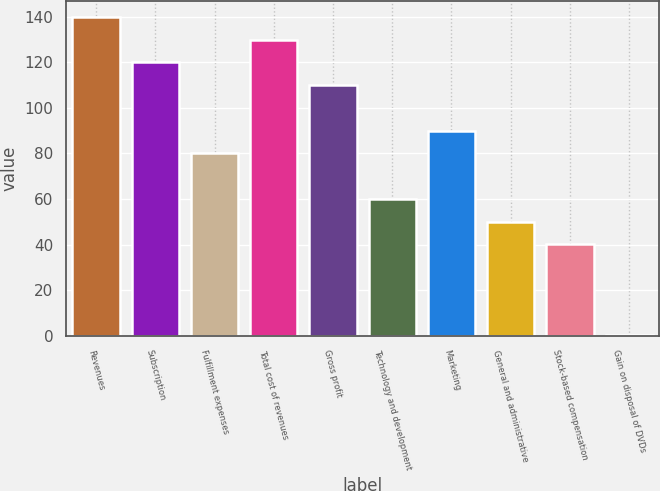Convert chart. <chart><loc_0><loc_0><loc_500><loc_500><bar_chart><fcel>Revenues<fcel>Subscription<fcel>Fulfillment expenses<fcel>Total cost of revenues<fcel>Gross profit<fcel>Technology and development<fcel>Marketing<fcel>General and administrative<fcel>Stock-based compensation<fcel>Gain on disposal of DVDs<nl><fcel>139.88<fcel>119.94<fcel>80.06<fcel>129.91<fcel>109.97<fcel>60.12<fcel>90.03<fcel>50.15<fcel>40.18<fcel>0.3<nl></chart> 